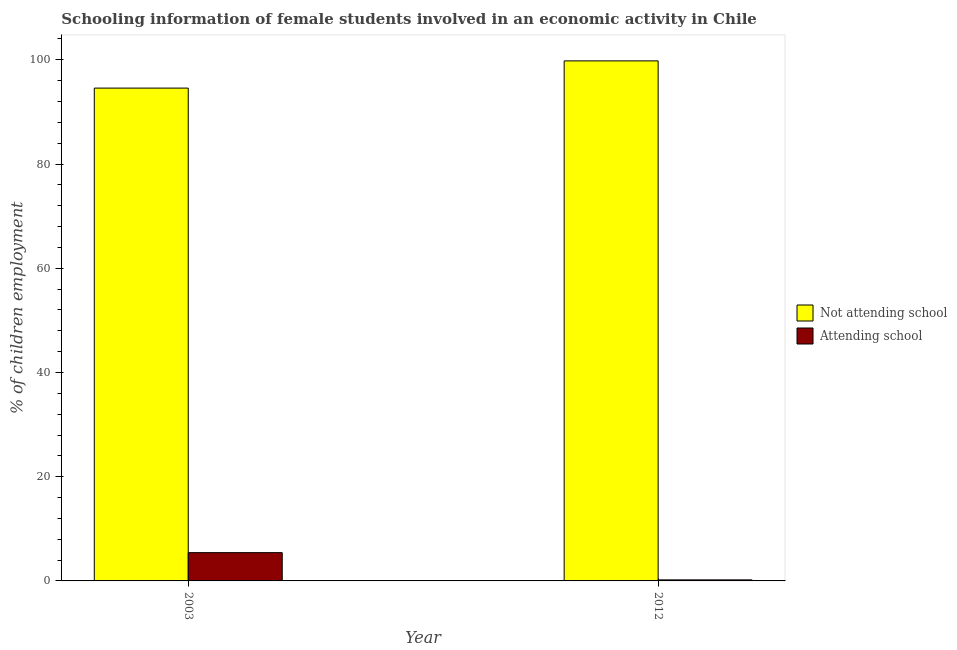How many different coloured bars are there?
Your answer should be compact. 2. How many bars are there on the 2nd tick from the left?
Offer a terse response. 2. What is the percentage of employed females who are attending school in 2003?
Your answer should be compact. 5.43. Across all years, what is the maximum percentage of employed females who are attending school?
Make the answer very short. 5.43. Across all years, what is the minimum percentage of employed females who are not attending school?
Provide a succinct answer. 94.57. What is the total percentage of employed females who are attending school in the graph?
Your answer should be very brief. 5.63. What is the difference between the percentage of employed females who are attending school in 2003 and that in 2012?
Keep it short and to the point. 5.23. What is the difference between the percentage of employed females who are attending school in 2012 and the percentage of employed females who are not attending school in 2003?
Your response must be concise. -5.23. What is the average percentage of employed females who are attending school per year?
Provide a succinct answer. 2.81. In the year 2012, what is the difference between the percentage of employed females who are attending school and percentage of employed females who are not attending school?
Keep it short and to the point. 0. In how many years, is the percentage of employed females who are not attending school greater than 64 %?
Your answer should be very brief. 2. What is the ratio of the percentage of employed females who are attending school in 2003 to that in 2012?
Provide a short and direct response. 27.13. Is the percentage of employed females who are attending school in 2003 less than that in 2012?
Provide a succinct answer. No. What does the 1st bar from the left in 2003 represents?
Provide a succinct answer. Not attending school. What does the 2nd bar from the right in 2003 represents?
Provide a succinct answer. Not attending school. What is the difference between two consecutive major ticks on the Y-axis?
Keep it short and to the point. 20. Are the values on the major ticks of Y-axis written in scientific E-notation?
Provide a short and direct response. No. Does the graph contain any zero values?
Provide a short and direct response. No. Does the graph contain grids?
Your answer should be compact. No. Where does the legend appear in the graph?
Provide a succinct answer. Center right. How many legend labels are there?
Offer a very short reply. 2. How are the legend labels stacked?
Provide a short and direct response. Vertical. What is the title of the graph?
Give a very brief answer. Schooling information of female students involved in an economic activity in Chile. What is the label or title of the Y-axis?
Your answer should be very brief. % of children employment. What is the % of children employment in Not attending school in 2003?
Keep it short and to the point. 94.57. What is the % of children employment of Attending school in 2003?
Provide a short and direct response. 5.43. What is the % of children employment of Not attending school in 2012?
Offer a very short reply. 99.8. What is the % of children employment in Attending school in 2012?
Offer a terse response. 0.2. Across all years, what is the maximum % of children employment of Not attending school?
Offer a very short reply. 99.8. Across all years, what is the maximum % of children employment in Attending school?
Your answer should be compact. 5.43. Across all years, what is the minimum % of children employment of Not attending school?
Give a very brief answer. 94.57. What is the total % of children employment of Not attending school in the graph?
Keep it short and to the point. 194.37. What is the total % of children employment of Attending school in the graph?
Make the answer very short. 5.63. What is the difference between the % of children employment of Not attending school in 2003 and that in 2012?
Give a very brief answer. -5.23. What is the difference between the % of children employment of Attending school in 2003 and that in 2012?
Keep it short and to the point. 5.23. What is the difference between the % of children employment in Not attending school in 2003 and the % of children employment in Attending school in 2012?
Provide a short and direct response. 94.37. What is the average % of children employment of Not attending school per year?
Provide a succinct answer. 97.19. What is the average % of children employment of Attending school per year?
Offer a very short reply. 2.81. In the year 2003, what is the difference between the % of children employment in Not attending school and % of children employment in Attending school?
Make the answer very short. 89.15. In the year 2012, what is the difference between the % of children employment in Not attending school and % of children employment in Attending school?
Offer a very short reply. 99.6. What is the ratio of the % of children employment in Not attending school in 2003 to that in 2012?
Your response must be concise. 0.95. What is the ratio of the % of children employment of Attending school in 2003 to that in 2012?
Provide a succinct answer. 27.13. What is the difference between the highest and the second highest % of children employment of Not attending school?
Your answer should be very brief. 5.23. What is the difference between the highest and the second highest % of children employment of Attending school?
Make the answer very short. 5.23. What is the difference between the highest and the lowest % of children employment of Not attending school?
Offer a terse response. 5.23. What is the difference between the highest and the lowest % of children employment of Attending school?
Provide a succinct answer. 5.23. 